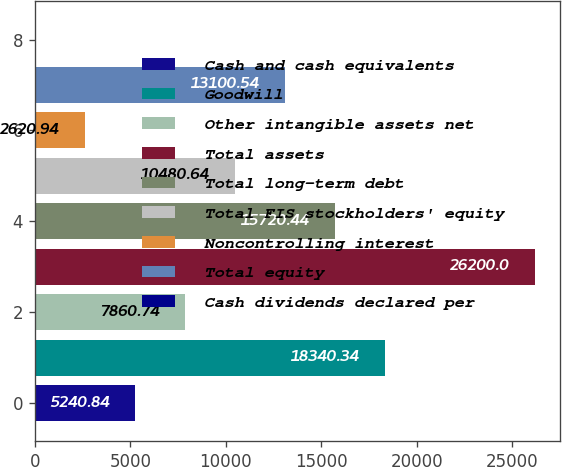<chart> <loc_0><loc_0><loc_500><loc_500><bar_chart><fcel>Cash and cash equivalents<fcel>Goodwill<fcel>Other intangible assets net<fcel>Total assets<fcel>Total long-term debt<fcel>Total FIS stockholders' equity<fcel>Noncontrolling interest<fcel>Total equity<fcel>Cash dividends declared per<nl><fcel>5240.84<fcel>18340.3<fcel>7860.74<fcel>26200<fcel>15720.4<fcel>10480.6<fcel>2620.94<fcel>13100.5<fcel>1.04<nl></chart> 